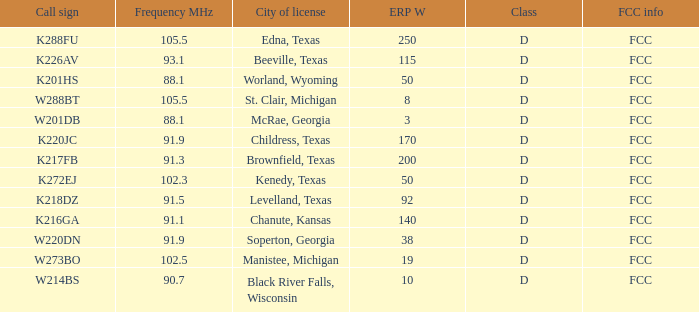What is City of License, when Frequency MHz is less than 102.5? McRae, Georgia, Soperton, Georgia, Chanute, Kansas, Beeville, Texas, Brownfield, Texas, Childress, Texas, Kenedy, Texas, Levelland, Texas, Black River Falls, Wisconsin, Worland, Wyoming. 